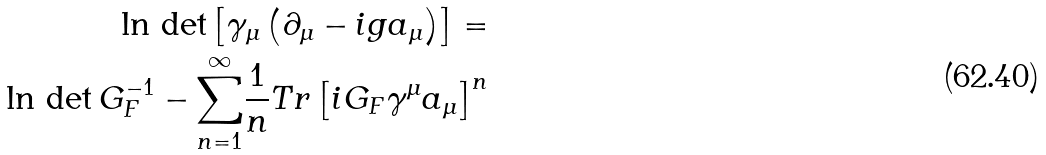Convert formula to latex. <formula><loc_0><loc_0><loc_500><loc_500>\ln \, \det \left [ \gamma _ { \mu } \left ( \partial _ { \mu } - i g a _ { \mu } \right ) \right ] = \\ \ln \, \det G _ { F } ^ { - 1 } - \overset { \infty } { \underset { n = 1 } { \sum } } \frac { 1 } { n } T r \left [ i G _ { F } \gamma ^ { \mu } a _ { \mu } \right ] ^ { n }</formula> 